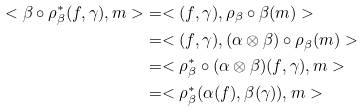Convert formula to latex. <formula><loc_0><loc_0><loc_500><loc_500>< \beta \circ \rho _ { \beta } ^ { * } ( f , \gamma ) , m > & = < ( f , \gamma ) , \rho _ { \beta } \circ \beta ( m ) > \\ & = < ( f , \gamma ) , ( \alpha \otimes \beta ) \circ \rho _ { \beta } ( m ) > \\ & = < \rho _ { \beta } ^ { * } \circ ( \alpha \otimes \beta ) ( f , \gamma ) , m > \\ & = < \rho _ { \beta } ^ { * } ( \alpha ( f ) , \beta ( \gamma ) ) , m ></formula> 